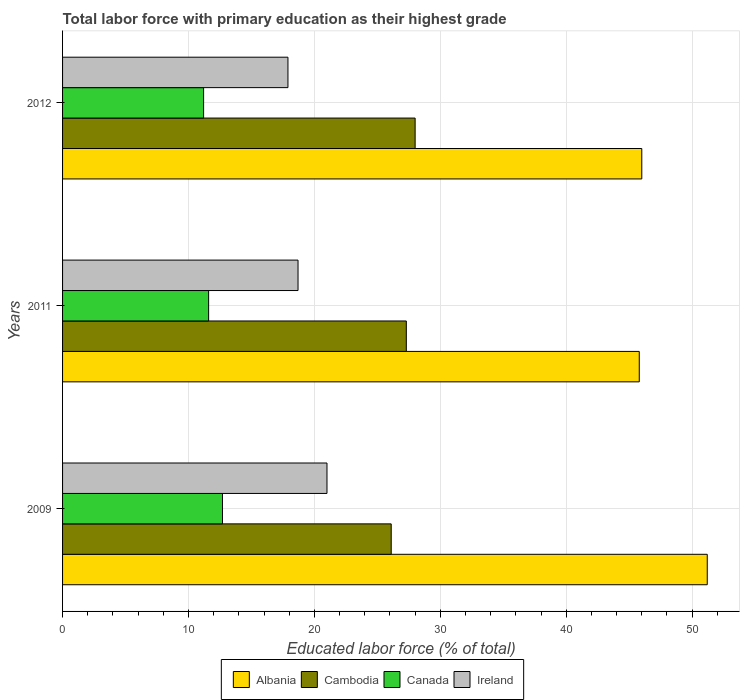How many different coloured bars are there?
Ensure brevity in your answer.  4. How many bars are there on the 2nd tick from the top?
Your answer should be very brief. 4. What is the label of the 1st group of bars from the top?
Ensure brevity in your answer.  2012. What is the percentage of total labor force with primary education in Cambodia in 2011?
Give a very brief answer. 27.3. Across all years, what is the minimum percentage of total labor force with primary education in Albania?
Ensure brevity in your answer.  45.8. What is the total percentage of total labor force with primary education in Ireland in the graph?
Offer a very short reply. 57.6. What is the difference between the percentage of total labor force with primary education in Albania in 2009 and that in 2012?
Your answer should be very brief. 5.2. What is the difference between the percentage of total labor force with primary education in Cambodia in 2009 and the percentage of total labor force with primary education in Albania in 2011?
Provide a short and direct response. -19.7. What is the average percentage of total labor force with primary education in Canada per year?
Your answer should be compact. 11.83. In the year 2012, what is the difference between the percentage of total labor force with primary education in Canada and percentage of total labor force with primary education in Albania?
Offer a very short reply. -34.8. What is the ratio of the percentage of total labor force with primary education in Albania in 2009 to that in 2012?
Make the answer very short. 1.11. Is the difference between the percentage of total labor force with primary education in Canada in 2011 and 2012 greater than the difference between the percentage of total labor force with primary education in Albania in 2011 and 2012?
Make the answer very short. Yes. What is the difference between the highest and the second highest percentage of total labor force with primary education in Albania?
Provide a succinct answer. 5.2. What is the difference between the highest and the lowest percentage of total labor force with primary education in Cambodia?
Offer a terse response. 1.9. What does the 4th bar from the top in 2009 represents?
Offer a terse response. Albania. What does the 1st bar from the bottom in 2012 represents?
Your answer should be compact. Albania. Is it the case that in every year, the sum of the percentage of total labor force with primary education in Ireland and percentage of total labor force with primary education in Albania is greater than the percentage of total labor force with primary education in Canada?
Your answer should be very brief. Yes. How many bars are there?
Offer a terse response. 12. What is the difference between two consecutive major ticks on the X-axis?
Your answer should be very brief. 10. Are the values on the major ticks of X-axis written in scientific E-notation?
Give a very brief answer. No. Does the graph contain any zero values?
Your response must be concise. No. Does the graph contain grids?
Provide a short and direct response. Yes. Where does the legend appear in the graph?
Ensure brevity in your answer.  Bottom center. What is the title of the graph?
Your response must be concise. Total labor force with primary education as their highest grade. What is the label or title of the X-axis?
Make the answer very short. Educated labor force (% of total). What is the Educated labor force (% of total) of Albania in 2009?
Your answer should be very brief. 51.2. What is the Educated labor force (% of total) of Cambodia in 2009?
Provide a short and direct response. 26.1. What is the Educated labor force (% of total) in Canada in 2009?
Provide a succinct answer. 12.7. What is the Educated labor force (% of total) of Ireland in 2009?
Keep it short and to the point. 21. What is the Educated labor force (% of total) in Albania in 2011?
Provide a short and direct response. 45.8. What is the Educated labor force (% of total) in Cambodia in 2011?
Your answer should be compact. 27.3. What is the Educated labor force (% of total) of Canada in 2011?
Make the answer very short. 11.6. What is the Educated labor force (% of total) in Ireland in 2011?
Ensure brevity in your answer.  18.7. What is the Educated labor force (% of total) of Canada in 2012?
Ensure brevity in your answer.  11.2. What is the Educated labor force (% of total) in Ireland in 2012?
Provide a short and direct response. 17.9. Across all years, what is the maximum Educated labor force (% of total) of Albania?
Your answer should be compact. 51.2. Across all years, what is the maximum Educated labor force (% of total) in Canada?
Your answer should be very brief. 12.7. Across all years, what is the minimum Educated labor force (% of total) in Albania?
Keep it short and to the point. 45.8. Across all years, what is the minimum Educated labor force (% of total) in Cambodia?
Your response must be concise. 26.1. Across all years, what is the minimum Educated labor force (% of total) in Canada?
Make the answer very short. 11.2. Across all years, what is the minimum Educated labor force (% of total) in Ireland?
Offer a very short reply. 17.9. What is the total Educated labor force (% of total) of Albania in the graph?
Make the answer very short. 143. What is the total Educated labor force (% of total) in Cambodia in the graph?
Your answer should be very brief. 81.4. What is the total Educated labor force (% of total) in Canada in the graph?
Provide a succinct answer. 35.5. What is the total Educated labor force (% of total) of Ireland in the graph?
Your answer should be very brief. 57.6. What is the difference between the Educated labor force (% of total) in Albania in 2009 and that in 2011?
Offer a terse response. 5.4. What is the difference between the Educated labor force (% of total) in Albania in 2009 and that in 2012?
Your response must be concise. 5.2. What is the difference between the Educated labor force (% of total) of Canada in 2011 and that in 2012?
Your response must be concise. 0.4. What is the difference between the Educated labor force (% of total) of Ireland in 2011 and that in 2012?
Your response must be concise. 0.8. What is the difference between the Educated labor force (% of total) in Albania in 2009 and the Educated labor force (% of total) in Cambodia in 2011?
Provide a succinct answer. 23.9. What is the difference between the Educated labor force (% of total) in Albania in 2009 and the Educated labor force (% of total) in Canada in 2011?
Offer a very short reply. 39.6. What is the difference between the Educated labor force (% of total) of Albania in 2009 and the Educated labor force (% of total) of Ireland in 2011?
Provide a succinct answer. 32.5. What is the difference between the Educated labor force (% of total) of Canada in 2009 and the Educated labor force (% of total) of Ireland in 2011?
Offer a terse response. -6. What is the difference between the Educated labor force (% of total) in Albania in 2009 and the Educated labor force (% of total) in Cambodia in 2012?
Your answer should be very brief. 23.2. What is the difference between the Educated labor force (% of total) of Albania in 2009 and the Educated labor force (% of total) of Ireland in 2012?
Ensure brevity in your answer.  33.3. What is the difference between the Educated labor force (% of total) of Canada in 2009 and the Educated labor force (% of total) of Ireland in 2012?
Your answer should be compact. -5.2. What is the difference between the Educated labor force (% of total) in Albania in 2011 and the Educated labor force (% of total) in Canada in 2012?
Offer a very short reply. 34.6. What is the difference between the Educated labor force (% of total) of Albania in 2011 and the Educated labor force (% of total) of Ireland in 2012?
Keep it short and to the point. 27.9. What is the difference between the Educated labor force (% of total) of Canada in 2011 and the Educated labor force (% of total) of Ireland in 2012?
Keep it short and to the point. -6.3. What is the average Educated labor force (% of total) in Albania per year?
Provide a short and direct response. 47.67. What is the average Educated labor force (% of total) in Cambodia per year?
Provide a succinct answer. 27.13. What is the average Educated labor force (% of total) in Canada per year?
Your answer should be compact. 11.83. In the year 2009, what is the difference between the Educated labor force (% of total) of Albania and Educated labor force (% of total) of Cambodia?
Your answer should be compact. 25.1. In the year 2009, what is the difference between the Educated labor force (% of total) of Albania and Educated labor force (% of total) of Canada?
Keep it short and to the point. 38.5. In the year 2009, what is the difference between the Educated labor force (% of total) in Albania and Educated labor force (% of total) in Ireland?
Offer a very short reply. 30.2. In the year 2009, what is the difference between the Educated labor force (% of total) in Cambodia and Educated labor force (% of total) in Ireland?
Make the answer very short. 5.1. In the year 2011, what is the difference between the Educated labor force (% of total) in Albania and Educated labor force (% of total) in Cambodia?
Your response must be concise. 18.5. In the year 2011, what is the difference between the Educated labor force (% of total) in Albania and Educated labor force (% of total) in Canada?
Your answer should be very brief. 34.2. In the year 2011, what is the difference between the Educated labor force (% of total) of Albania and Educated labor force (% of total) of Ireland?
Offer a terse response. 27.1. In the year 2011, what is the difference between the Educated labor force (% of total) of Cambodia and Educated labor force (% of total) of Canada?
Your answer should be compact. 15.7. In the year 2011, what is the difference between the Educated labor force (% of total) in Canada and Educated labor force (% of total) in Ireland?
Your answer should be very brief. -7.1. In the year 2012, what is the difference between the Educated labor force (% of total) of Albania and Educated labor force (% of total) of Cambodia?
Make the answer very short. 18. In the year 2012, what is the difference between the Educated labor force (% of total) in Albania and Educated labor force (% of total) in Canada?
Your response must be concise. 34.8. In the year 2012, what is the difference between the Educated labor force (% of total) of Albania and Educated labor force (% of total) of Ireland?
Offer a terse response. 28.1. In the year 2012, what is the difference between the Educated labor force (% of total) in Cambodia and Educated labor force (% of total) in Canada?
Offer a very short reply. 16.8. In the year 2012, what is the difference between the Educated labor force (% of total) in Cambodia and Educated labor force (% of total) in Ireland?
Offer a very short reply. 10.1. What is the ratio of the Educated labor force (% of total) of Albania in 2009 to that in 2011?
Ensure brevity in your answer.  1.12. What is the ratio of the Educated labor force (% of total) in Cambodia in 2009 to that in 2011?
Offer a terse response. 0.96. What is the ratio of the Educated labor force (% of total) in Canada in 2009 to that in 2011?
Provide a succinct answer. 1.09. What is the ratio of the Educated labor force (% of total) in Ireland in 2009 to that in 2011?
Your answer should be very brief. 1.12. What is the ratio of the Educated labor force (% of total) of Albania in 2009 to that in 2012?
Provide a succinct answer. 1.11. What is the ratio of the Educated labor force (% of total) in Cambodia in 2009 to that in 2012?
Your answer should be compact. 0.93. What is the ratio of the Educated labor force (% of total) of Canada in 2009 to that in 2012?
Offer a terse response. 1.13. What is the ratio of the Educated labor force (% of total) in Ireland in 2009 to that in 2012?
Offer a terse response. 1.17. What is the ratio of the Educated labor force (% of total) in Canada in 2011 to that in 2012?
Your response must be concise. 1.04. What is the ratio of the Educated labor force (% of total) of Ireland in 2011 to that in 2012?
Ensure brevity in your answer.  1.04. What is the difference between the highest and the second highest Educated labor force (% of total) of Cambodia?
Keep it short and to the point. 0.7. What is the difference between the highest and the second highest Educated labor force (% of total) of Ireland?
Your response must be concise. 2.3. What is the difference between the highest and the lowest Educated labor force (% of total) of Albania?
Give a very brief answer. 5.4. What is the difference between the highest and the lowest Educated labor force (% of total) in Canada?
Your response must be concise. 1.5. 